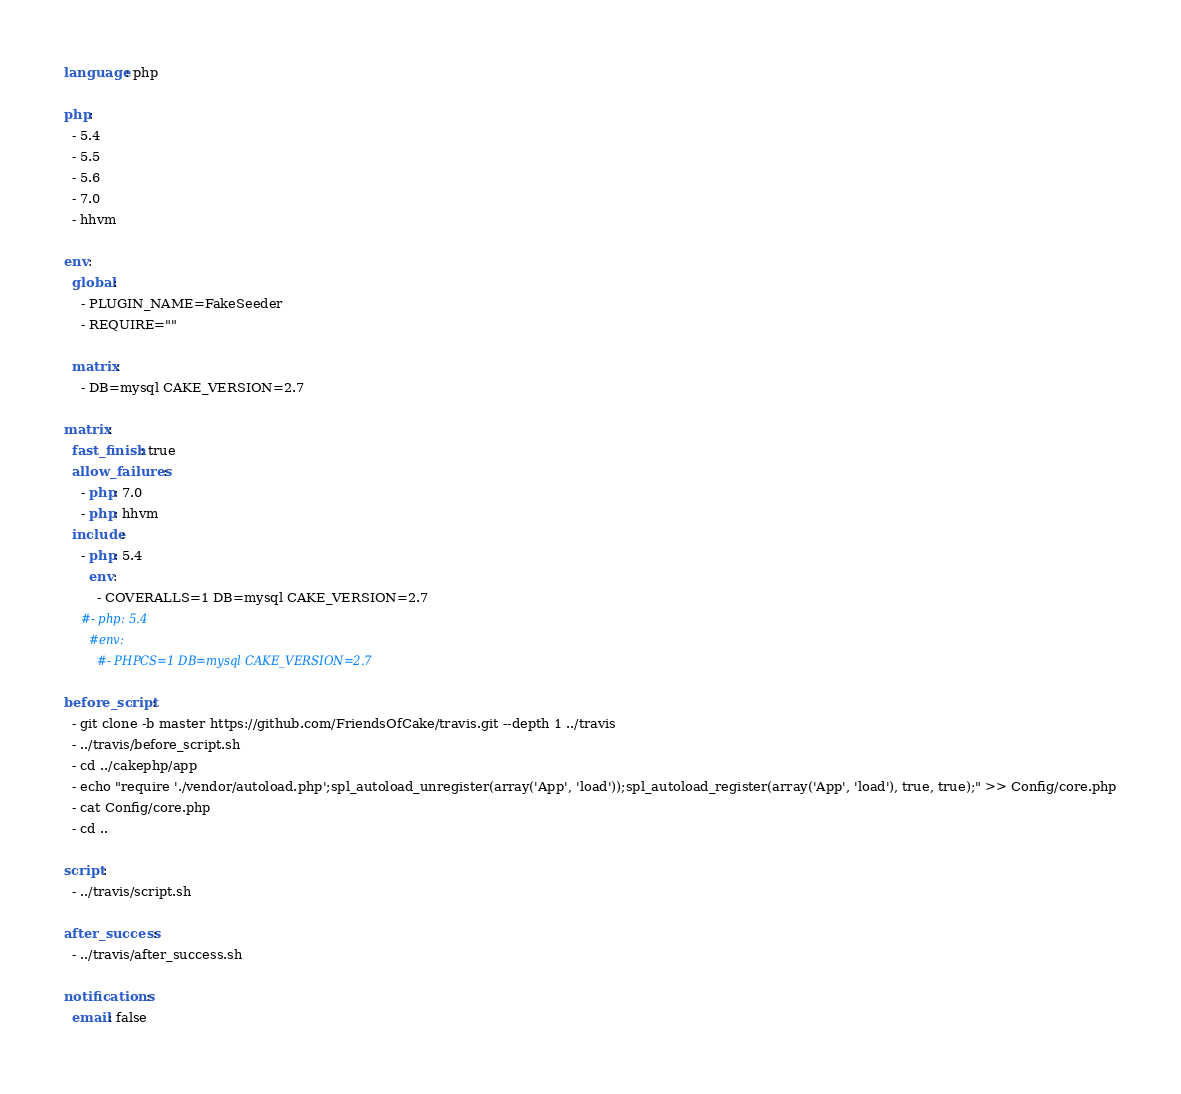<code> <loc_0><loc_0><loc_500><loc_500><_YAML_>language: php

php:
  - 5.4
  - 5.5
  - 5.6
  - 7.0
  - hhvm

env:
  global:
    - PLUGIN_NAME=FakeSeeder
    - REQUIRE=""

  matrix:
    - DB=mysql CAKE_VERSION=2.7

matrix:
  fast_finish: true
  allow_failures:
    - php: 7.0
    - php: hhvm
  include:
    - php: 5.4
      env:
        - COVERALLS=1 DB=mysql CAKE_VERSION=2.7
    #- php: 5.4
      #env:
        #- PHPCS=1 DB=mysql CAKE_VERSION=2.7

before_script:
  - git clone -b master https://github.com/FriendsOfCake/travis.git --depth 1 ../travis
  - ../travis/before_script.sh
  - cd ../cakephp/app
  - echo "require './vendor/autoload.php';spl_autoload_unregister(array('App', 'load'));spl_autoload_register(array('App', 'load'), true, true);" >> Config/core.php
  - cat Config/core.php
  - cd ..

script:
  - ../travis/script.sh

after_success:
  - ../travis/after_success.sh

notifications:
  email: false
</code> 